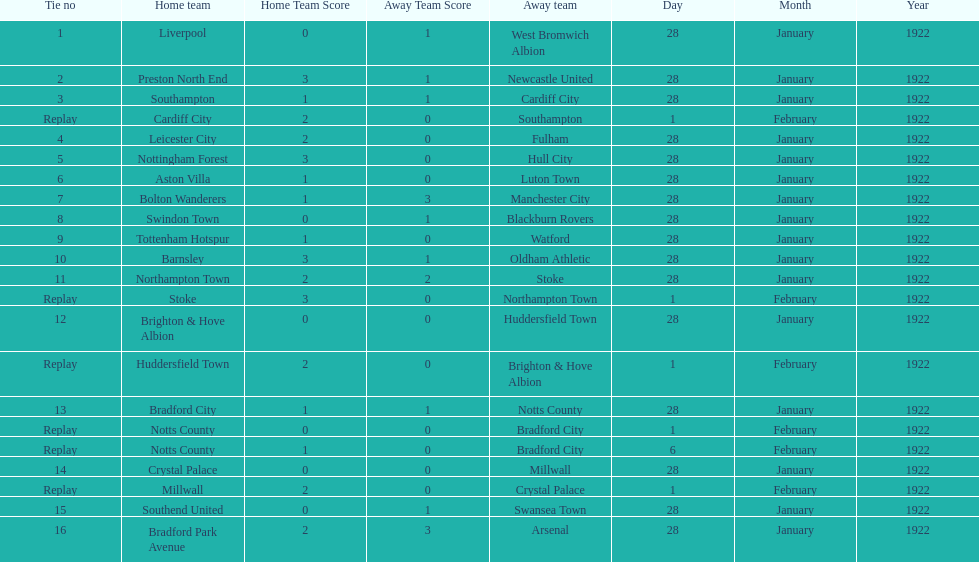What home team had the same score as aston villa on january 28th, 1922? Tottenham Hotspur. 